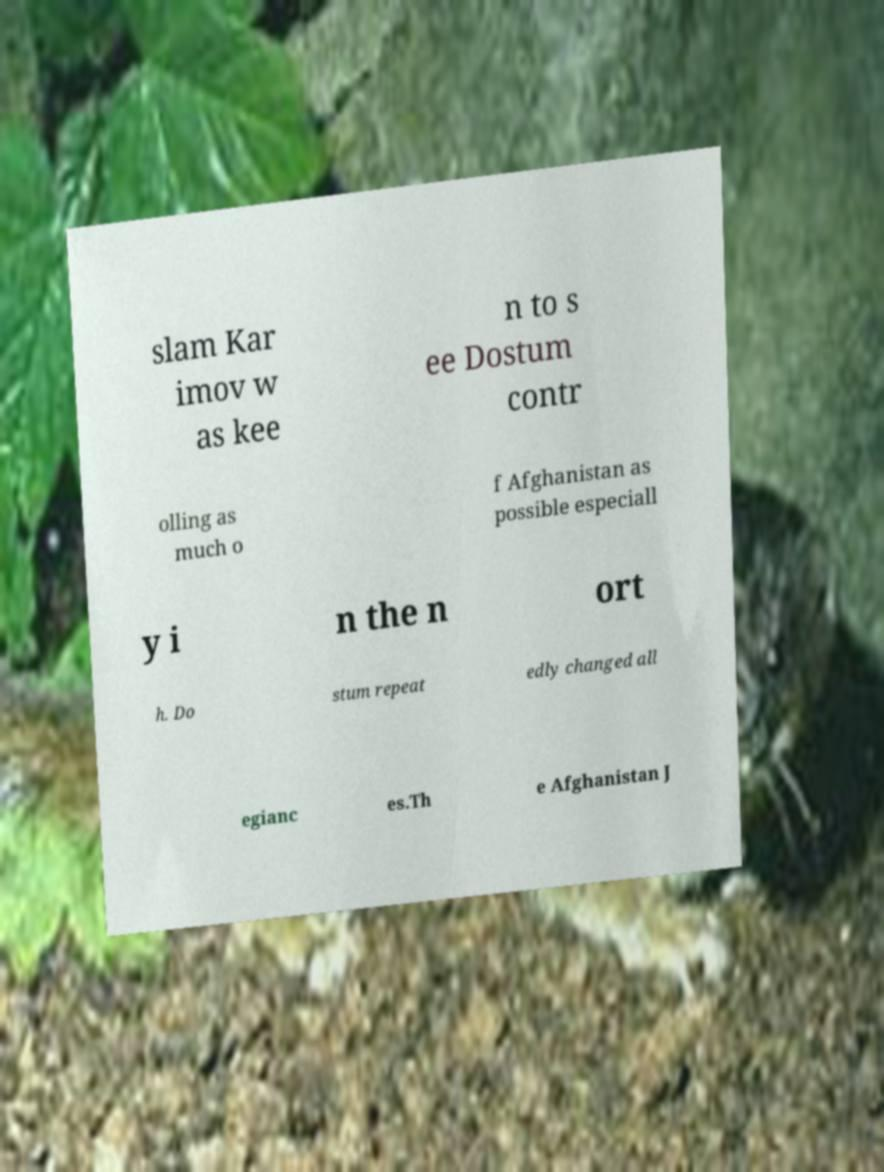Could you assist in decoding the text presented in this image and type it out clearly? slam Kar imov w as kee n to s ee Dostum contr olling as much o f Afghanistan as possible especiall y i n the n ort h. Do stum repeat edly changed all egianc es.Th e Afghanistan J 